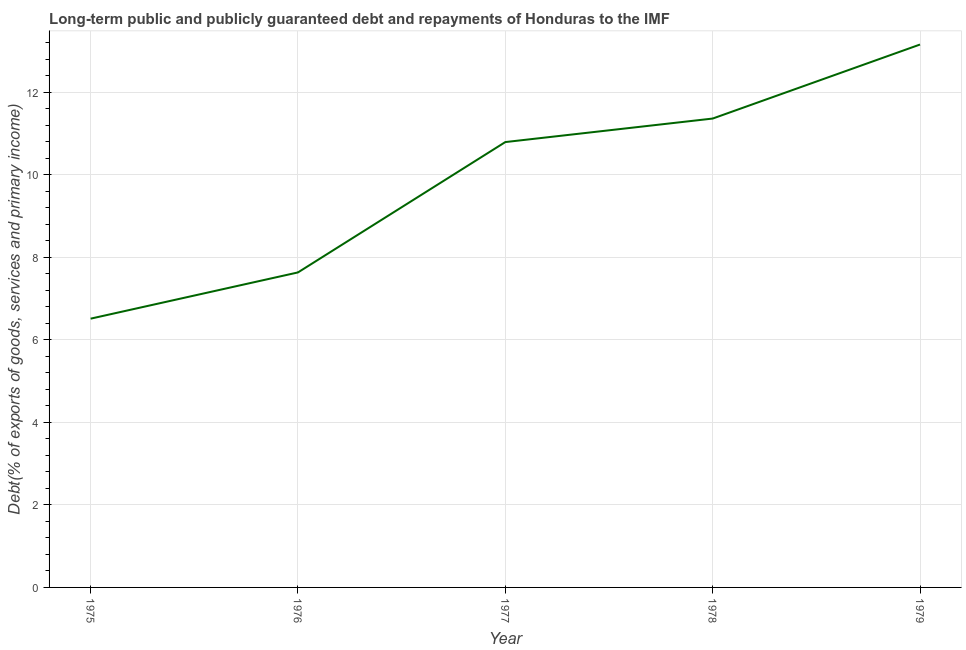What is the debt service in 1979?
Provide a short and direct response. 13.15. Across all years, what is the maximum debt service?
Provide a short and direct response. 13.15. Across all years, what is the minimum debt service?
Your answer should be compact. 6.51. In which year was the debt service maximum?
Provide a short and direct response. 1979. In which year was the debt service minimum?
Give a very brief answer. 1975. What is the sum of the debt service?
Your answer should be very brief. 49.45. What is the difference between the debt service in 1975 and 1979?
Make the answer very short. -6.64. What is the average debt service per year?
Ensure brevity in your answer.  9.89. What is the median debt service?
Give a very brief answer. 10.79. What is the ratio of the debt service in 1976 to that in 1978?
Provide a succinct answer. 0.67. What is the difference between the highest and the second highest debt service?
Keep it short and to the point. 1.79. Is the sum of the debt service in 1976 and 1977 greater than the maximum debt service across all years?
Your answer should be very brief. Yes. What is the difference between the highest and the lowest debt service?
Offer a very short reply. 6.64. Does the debt service monotonically increase over the years?
Your answer should be compact. Yes. How many years are there in the graph?
Keep it short and to the point. 5. What is the difference between two consecutive major ticks on the Y-axis?
Your response must be concise. 2. Are the values on the major ticks of Y-axis written in scientific E-notation?
Make the answer very short. No. Does the graph contain any zero values?
Your answer should be very brief. No. Does the graph contain grids?
Provide a short and direct response. Yes. What is the title of the graph?
Provide a succinct answer. Long-term public and publicly guaranteed debt and repayments of Honduras to the IMF. What is the label or title of the X-axis?
Make the answer very short. Year. What is the label or title of the Y-axis?
Your answer should be very brief. Debt(% of exports of goods, services and primary income). What is the Debt(% of exports of goods, services and primary income) in 1975?
Offer a very short reply. 6.51. What is the Debt(% of exports of goods, services and primary income) of 1976?
Your answer should be compact. 7.63. What is the Debt(% of exports of goods, services and primary income) in 1977?
Provide a short and direct response. 10.79. What is the Debt(% of exports of goods, services and primary income) in 1978?
Provide a short and direct response. 11.36. What is the Debt(% of exports of goods, services and primary income) in 1979?
Ensure brevity in your answer.  13.15. What is the difference between the Debt(% of exports of goods, services and primary income) in 1975 and 1976?
Your response must be concise. -1.12. What is the difference between the Debt(% of exports of goods, services and primary income) in 1975 and 1977?
Your answer should be compact. -4.28. What is the difference between the Debt(% of exports of goods, services and primary income) in 1975 and 1978?
Make the answer very short. -4.85. What is the difference between the Debt(% of exports of goods, services and primary income) in 1975 and 1979?
Your response must be concise. -6.64. What is the difference between the Debt(% of exports of goods, services and primary income) in 1976 and 1977?
Give a very brief answer. -3.16. What is the difference between the Debt(% of exports of goods, services and primary income) in 1976 and 1978?
Offer a terse response. -3.73. What is the difference between the Debt(% of exports of goods, services and primary income) in 1976 and 1979?
Your answer should be compact. -5.52. What is the difference between the Debt(% of exports of goods, services and primary income) in 1977 and 1978?
Make the answer very short. -0.57. What is the difference between the Debt(% of exports of goods, services and primary income) in 1977 and 1979?
Your answer should be very brief. -2.36. What is the difference between the Debt(% of exports of goods, services and primary income) in 1978 and 1979?
Keep it short and to the point. -1.79. What is the ratio of the Debt(% of exports of goods, services and primary income) in 1975 to that in 1976?
Offer a very short reply. 0.85. What is the ratio of the Debt(% of exports of goods, services and primary income) in 1975 to that in 1977?
Your response must be concise. 0.6. What is the ratio of the Debt(% of exports of goods, services and primary income) in 1975 to that in 1978?
Provide a succinct answer. 0.57. What is the ratio of the Debt(% of exports of goods, services and primary income) in 1975 to that in 1979?
Give a very brief answer. 0.49. What is the ratio of the Debt(% of exports of goods, services and primary income) in 1976 to that in 1977?
Make the answer very short. 0.71. What is the ratio of the Debt(% of exports of goods, services and primary income) in 1976 to that in 1978?
Give a very brief answer. 0.67. What is the ratio of the Debt(% of exports of goods, services and primary income) in 1976 to that in 1979?
Your response must be concise. 0.58. What is the ratio of the Debt(% of exports of goods, services and primary income) in 1977 to that in 1979?
Your answer should be very brief. 0.82. What is the ratio of the Debt(% of exports of goods, services and primary income) in 1978 to that in 1979?
Your response must be concise. 0.86. 